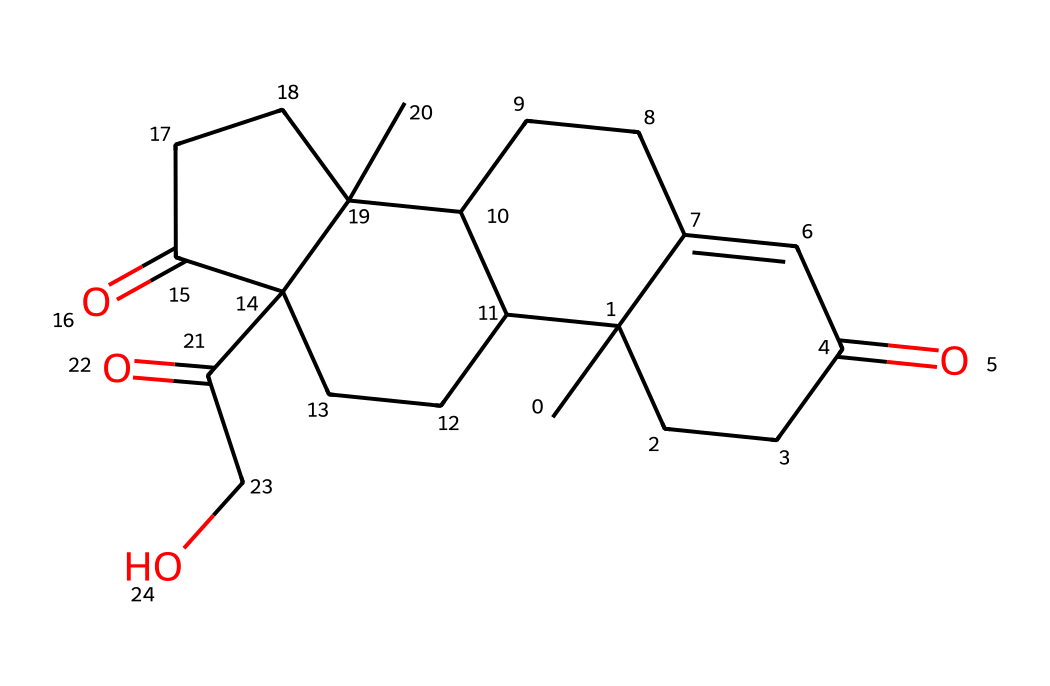What is the molecular formula of cortisol based on the SMILES representation? The SMILES representation indicates the presence of carbon (C), hydrogen (H), and oxygen (O) atoms. Counting each can help in deriving the molecular formula. In this case, there are 21 carbons, 30 hydrogens, and 5 oxygens, hence the molecular formula is C21H30O5.
Answer: C21H30O5 How many rings are present in the structure of cortisol? By analyzing the structure represented in SMILES, we can identify that cortisol features four interconnected rings typical for steroid hormones. The 'C' in the SMILES shows where these rings are connected.
Answer: 4 What type of functional groups are present in cortisol? Reviewing the SMILES shows that the molecule contains ketone groups (C=O) and hydroxyl groups (–OH). These functional groups are commonly found in cortisol, impacting its hormonal activity.
Answer: ketone and hydroxyl Which element is present as the least abundant in cortisol? The analysis of the molecular composition derived from the SMILES shows that after counting atoms, oxygen appears less frequently than carbon and hydrogen. Identifying this shows that oxygen is the least abundant element in this molecule.
Answer: oxygen Is cortisol a type of steroid hormone? Cortisol, being a product of the steroidogenesis pathway and characterized by its four-ring structure (common in steroids), confirms it as a steroid hormone. Thus, the answer stems from recognizing the structural characteristics.
Answer: yes 